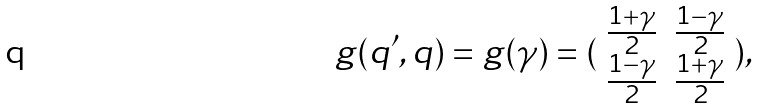Convert formula to latex. <formula><loc_0><loc_0><loc_500><loc_500>g ( q ^ { \prime } , q ) = g ( \gamma ) = ( \begin{array} { c c } \frac { 1 + \gamma } { 2 } & \frac { 1 - \gamma } { 2 } \\ \frac { 1 - \gamma } { 2 } & \frac { 1 + \gamma } { 2 } \end{array} ) ,</formula> 